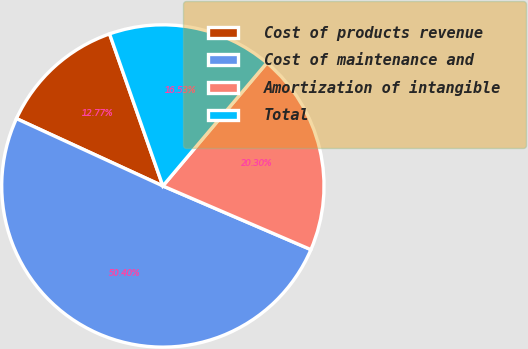Convert chart. <chart><loc_0><loc_0><loc_500><loc_500><pie_chart><fcel>Cost of products revenue<fcel>Cost of maintenance and<fcel>Amortization of intangible<fcel>Total<nl><fcel>12.77%<fcel>50.4%<fcel>20.3%<fcel>16.53%<nl></chart> 